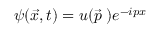Convert formula to latex. <formula><loc_0><loc_0><loc_500><loc_500>\psi ( \vec { x } , t ) = u ( \vec { p } \, ) e ^ { - i p x }</formula> 